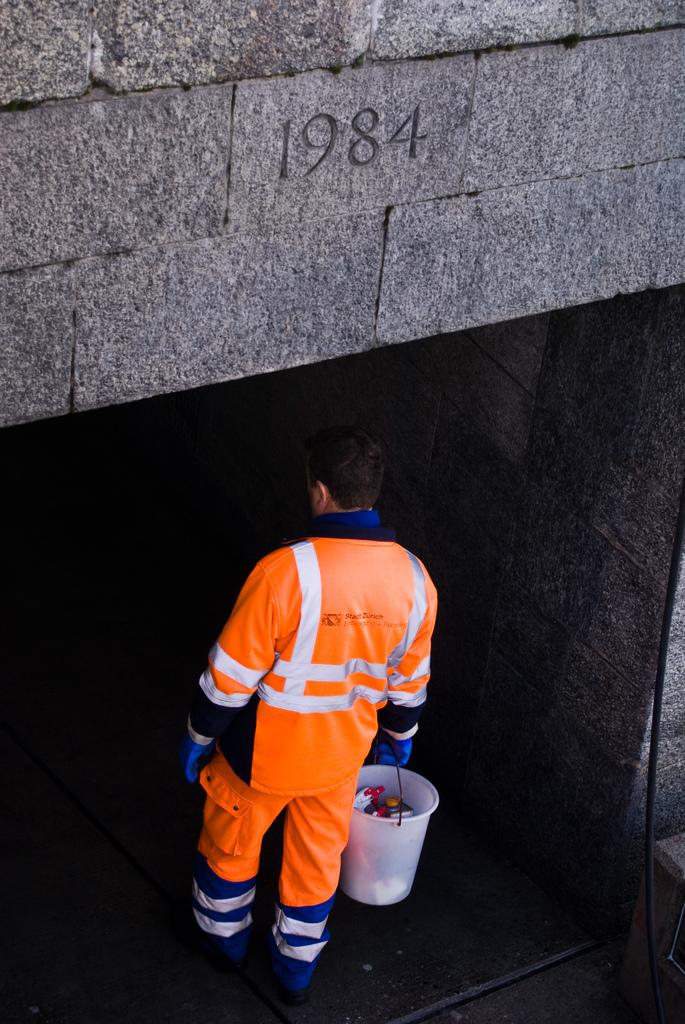When was this structure built?
Provide a succinct answer. 1984. 